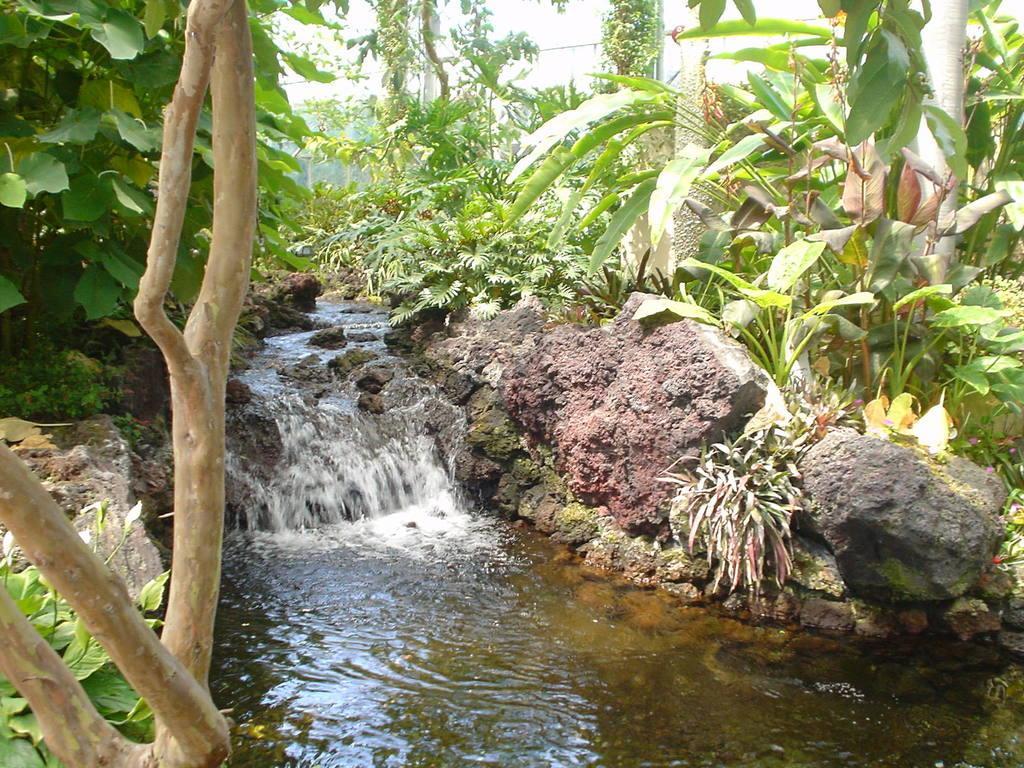Can you describe this image briefly? In this picture, we can see water, plants, trees and stones. 